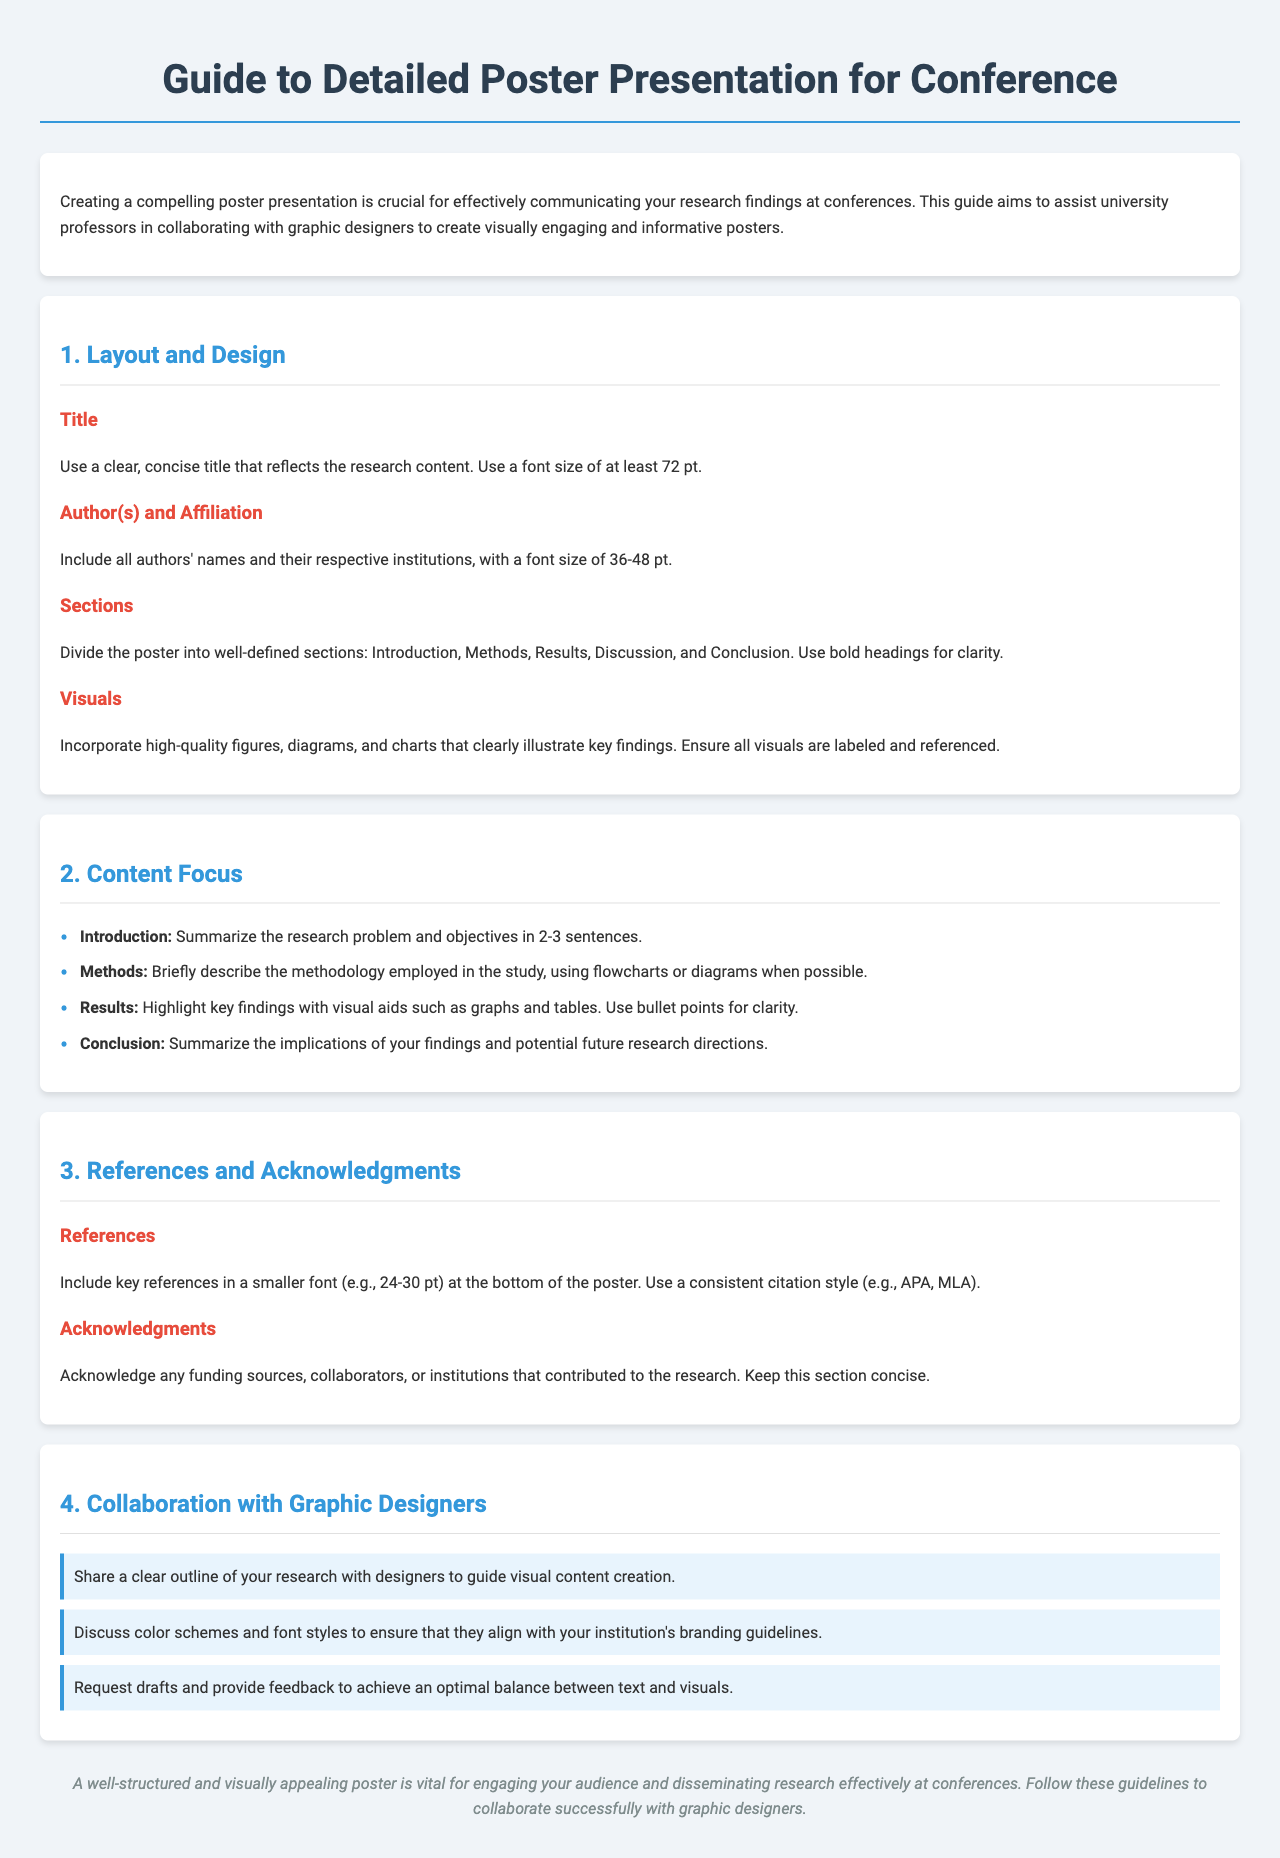What is the title of the document? The title is found in the header of the document, which specifies the main focus.
Answer: Guide to Detailed Poster Presentation for Conference What should the font size be for the title? The document specifies the appropriate font size for the title to ensure visibility.
Answer: At least 72 pt How many main sections are listed in the document? The document outlines the main topics of discussion, which can be counted to determine this.
Answer: Four What is the suggested font size for references? The document provides details on the font size for references to ensure readability.
Answer: 24-30 pt What color is used for section headings? The document mentions the font color used for headings, which is a common design element.
Answer: #3498db What should you provide to graphic designers for effective collaboration? The document highlights key information that should be shared with designers to facilitate useful visuals.
Answer: A clear outline of your research What is the maximum width of the document layout? The document specifies a width for layout consistency, which helps in visual presentation.
Answer: 1200 px What is the purpose of using visuals in a poster? The document outlines the importance and function of including visuals in poster presentations.
Answer: Clearly illustrate key findings 